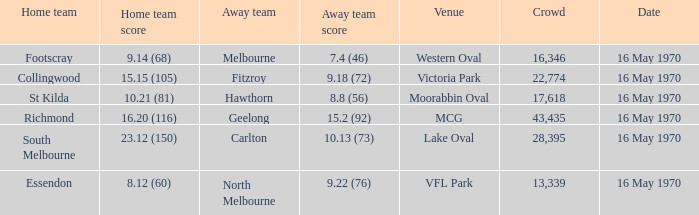Who was the away team at western oval? Melbourne. 